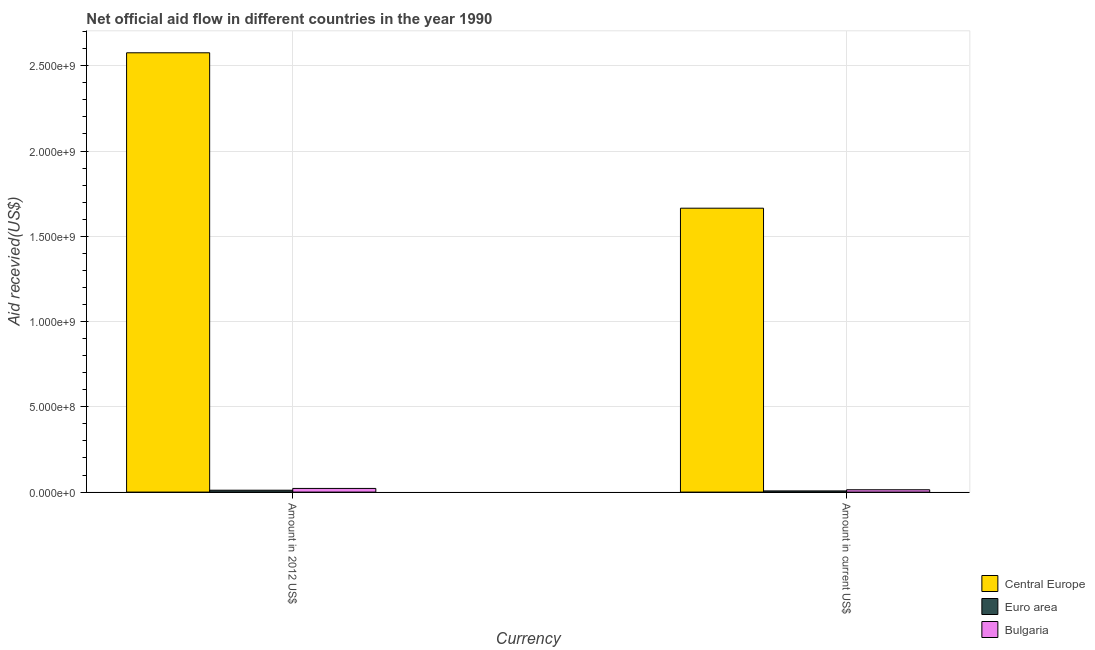How many different coloured bars are there?
Provide a succinct answer. 3. How many groups of bars are there?
Keep it short and to the point. 2. Are the number of bars per tick equal to the number of legend labels?
Your response must be concise. Yes. What is the label of the 2nd group of bars from the left?
Offer a very short reply. Amount in current US$. What is the amount of aid received(expressed in us$) in Bulgaria?
Your answer should be compact. 1.36e+07. Across all countries, what is the maximum amount of aid received(expressed in us$)?
Offer a very short reply. 1.66e+09. Across all countries, what is the minimum amount of aid received(expressed in 2012 us$)?
Provide a short and direct response. 1.10e+07. In which country was the amount of aid received(expressed in 2012 us$) maximum?
Your answer should be very brief. Central Europe. In which country was the amount of aid received(expressed in us$) minimum?
Your response must be concise. Euro area. What is the total amount of aid received(expressed in us$) in the graph?
Your response must be concise. 1.69e+09. What is the difference between the amount of aid received(expressed in us$) in Central Europe and that in Bulgaria?
Your response must be concise. 1.65e+09. What is the difference between the amount of aid received(expressed in 2012 us$) in Central Europe and the amount of aid received(expressed in us$) in Bulgaria?
Offer a very short reply. 2.56e+09. What is the average amount of aid received(expressed in us$) per country?
Offer a terse response. 5.62e+08. What is the difference between the amount of aid received(expressed in 2012 us$) and amount of aid received(expressed in us$) in Bulgaria?
Give a very brief answer. 7.87e+06. What is the ratio of the amount of aid received(expressed in 2012 us$) in Bulgaria to that in Euro area?
Offer a terse response. 1.96. Is the amount of aid received(expressed in 2012 us$) in Bulgaria less than that in Central Europe?
Ensure brevity in your answer.  Yes. What does the 1st bar from the left in Amount in 2012 US$ represents?
Provide a short and direct response. Central Europe. What does the 2nd bar from the right in Amount in 2012 US$ represents?
Your response must be concise. Euro area. Are all the bars in the graph horizontal?
Your response must be concise. No. How many countries are there in the graph?
Your answer should be very brief. 3. What is the difference between two consecutive major ticks on the Y-axis?
Offer a terse response. 5.00e+08. Does the graph contain any zero values?
Ensure brevity in your answer.  No. Does the graph contain grids?
Provide a succinct answer. Yes. How many legend labels are there?
Offer a terse response. 3. What is the title of the graph?
Offer a terse response. Net official aid flow in different countries in the year 1990. What is the label or title of the X-axis?
Provide a short and direct response. Currency. What is the label or title of the Y-axis?
Ensure brevity in your answer.  Aid recevied(US$). What is the Aid recevied(US$) of Central Europe in Amount in 2012 US$?
Keep it short and to the point. 2.58e+09. What is the Aid recevied(US$) of Euro area in Amount in 2012 US$?
Ensure brevity in your answer.  1.10e+07. What is the Aid recevied(US$) of Bulgaria in Amount in 2012 US$?
Keep it short and to the point. 2.15e+07. What is the Aid recevied(US$) in Central Europe in Amount in current US$?
Offer a very short reply. 1.66e+09. What is the Aid recevied(US$) in Euro area in Amount in current US$?
Provide a short and direct response. 6.84e+06. What is the Aid recevied(US$) of Bulgaria in Amount in current US$?
Your answer should be very brief. 1.36e+07. Across all Currency, what is the maximum Aid recevied(US$) of Central Europe?
Offer a terse response. 2.58e+09. Across all Currency, what is the maximum Aid recevied(US$) of Euro area?
Your answer should be very brief. 1.10e+07. Across all Currency, what is the maximum Aid recevied(US$) in Bulgaria?
Offer a terse response. 2.15e+07. Across all Currency, what is the minimum Aid recevied(US$) of Central Europe?
Ensure brevity in your answer.  1.66e+09. Across all Currency, what is the minimum Aid recevied(US$) in Euro area?
Your response must be concise. 6.84e+06. Across all Currency, what is the minimum Aid recevied(US$) in Bulgaria?
Give a very brief answer. 1.36e+07. What is the total Aid recevied(US$) in Central Europe in the graph?
Keep it short and to the point. 4.24e+09. What is the total Aid recevied(US$) in Euro area in the graph?
Ensure brevity in your answer.  1.78e+07. What is the total Aid recevied(US$) of Bulgaria in the graph?
Your response must be concise. 3.51e+07. What is the difference between the Aid recevied(US$) of Central Europe in Amount in 2012 US$ and that in Amount in current US$?
Keep it short and to the point. 9.11e+08. What is the difference between the Aid recevied(US$) of Euro area in Amount in 2012 US$ and that in Amount in current US$?
Provide a short and direct response. 4.15e+06. What is the difference between the Aid recevied(US$) in Bulgaria in Amount in 2012 US$ and that in Amount in current US$?
Provide a short and direct response. 7.87e+06. What is the difference between the Aid recevied(US$) of Central Europe in Amount in 2012 US$ and the Aid recevied(US$) of Euro area in Amount in current US$?
Your answer should be compact. 2.57e+09. What is the difference between the Aid recevied(US$) in Central Europe in Amount in 2012 US$ and the Aid recevied(US$) in Bulgaria in Amount in current US$?
Offer a terse response. 2.56e+09. What is the difference between the Aid recevied(US$) in Euro area in Amount in 2012 US$ and the Aid recevied(US$) in Bulgaria in Amount in current US$?
Your response must be concise. -2.63e+06. What is the average Aid recevied(US$) of Central Europe per Currency?
Your answer should be very brief. 2.12e+09. What is the average Aid recevied(US$) in Euro area per Currency?
Provide a succinct answer. 8.92e+06. What is the average Aid recevied(US$) of Bulgaria per Currency?
Ensure brevity in your answer.  1.76e+07. What is the difference between the Aid recevied(US$) of Central Europe and Aid recevied(US$) of Euro area in Amount in 2012 US$?
Ensure brevity in your answer.  2.57e+09. What is the difference between the Aid recevied(US$) in Central Europe and Aid recevied(US$) in Bulgaria in Amount in 2012 US$?
Provide a succinct answer. 2.55e+09. What is the difference between the Aid recevied(US$) of Euro area and Aid recevied(US$) of Bulgaria in Amount in 2012 US$?
Your answer should be very brief. -1.05e+07. What is the difference between the Aid recevied(US$) in Central Europe and Aid recevied(US$) in Euro area in Amount in current US$?
Give a very brief answer. 1.66e+09. What is the difference between the Aid recevied(US$) in Central Europe and Aid recevied(US$) in Bulgaria in Amount in current US$?
Make the answer very short. 1.65e+09. What is the difference between the Aid recevied(US$) of Euro area and Aid recevied(US$) of Bulgaria in Amount in current US$?
Your answer should be very brief. -6.78e+06. What is the ratio of the Aid recevied(US$) of Central Europe in Amount in 2012 US$ to that in Amount in current US$?
Make the answer very short. 1.55. What is the ratio of the Aid recevied(US$) of Euro area in Amount in 2012 US$ to that in Amount in current US$?
Your answer should be very brief. 1.61. What is the ratio of the Aid recevied(US$) of Bulgaria in Amount in 2012 US$ to that in Amount in current US$?
Offer a terse response. 1.58. What is the difference between the highest and the second highest Aid recevied(US$) in Central Europe?
Ensure brevity in your answer.  9.11e+08. What is the difference between the highest and the second highest Aid recevied(US$) in Euro area?
Keep it short and to the point. 4.15e+06. What is the difference between the highest and the second highest Aid recevied(US$) in Bulgaria?
Provide a succinct answer. 7.87e+06. What is the difference between the highest and the lowest Aid recevied(US$) in Central Europe?
Your answer should be very brief. 9.11e+08. What is the difference between the highest and the lowest Aid recevied(US$) in Euro area?
Provide a succinct answer. 4.15e+06. What is the difference between the highest and the lowest Aid recevied(US$) in Bulgaria?
Your response must be concise. 7.87e+06. 